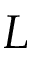<formula> <loc_0><loc_0><loc_500><loc_500>L</formula> 